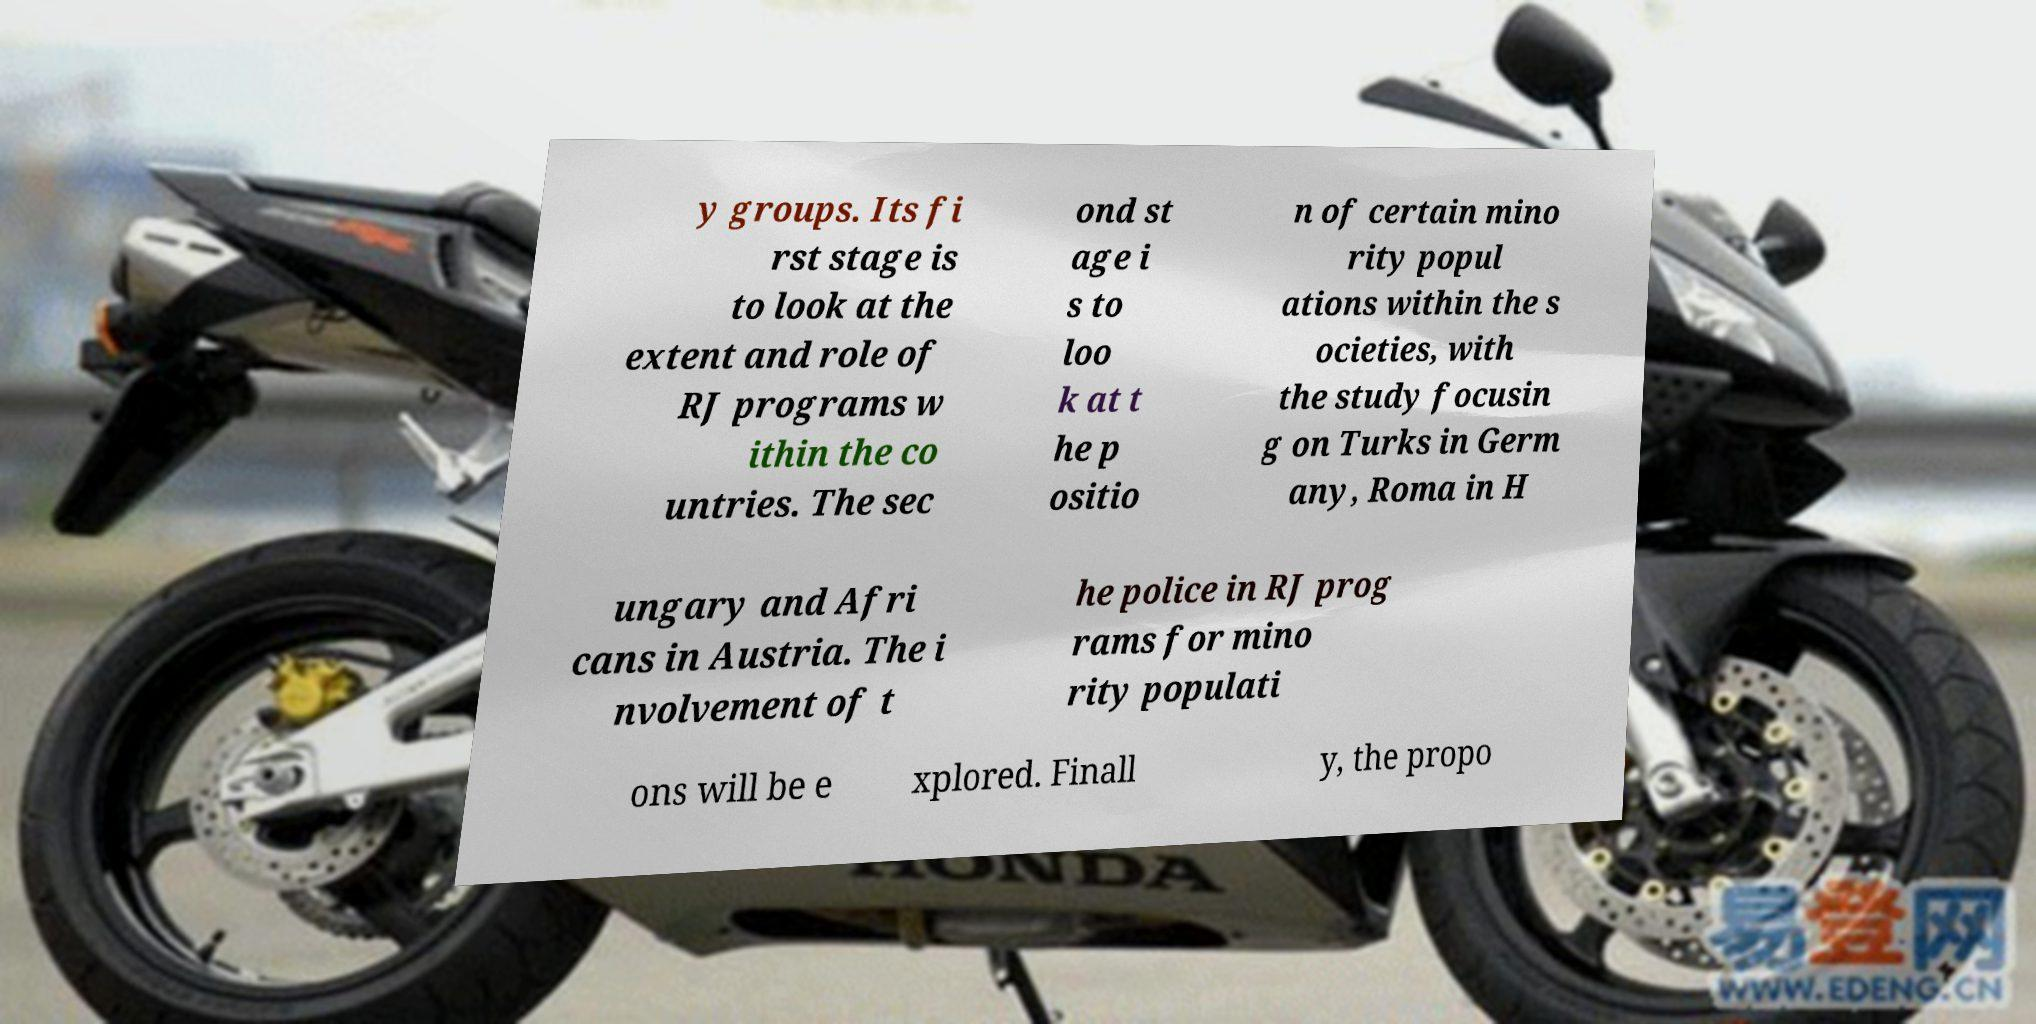There's text embedded in this image that I need extracted. Can you transcribe it verbatim? y groups. Its fi rst stage is to look at the extent and role of RJ programs w ithin the co untries. The sec ond st age i s to loo k at t he p ositio n of certain mino rity popul ations within the s ocieties, with the study focusin g on Turks in Germ any, Roma in H ungary and Afri cans in Austria. The i nvolvement of t he police in RJ prog rams for mino rity populati ons will be e xplored. Finall y, the propo 